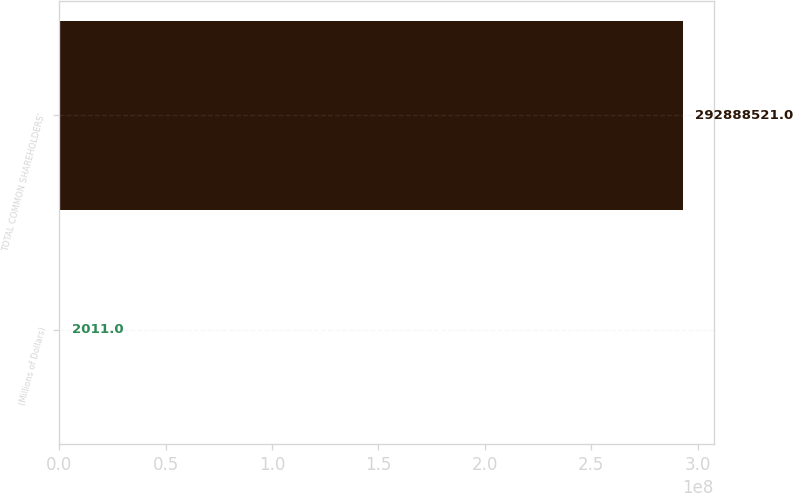Convert chart to OTSL. <chart><loc_0><loc_0><loc_500><loc_500><bar_chart><fcel>(Millions of Dollars)<fcel>TOTAL COMMON SHAREHOLDERS'<nl><fcel>2011<fcel>2.92889e+08<nl></chart> 